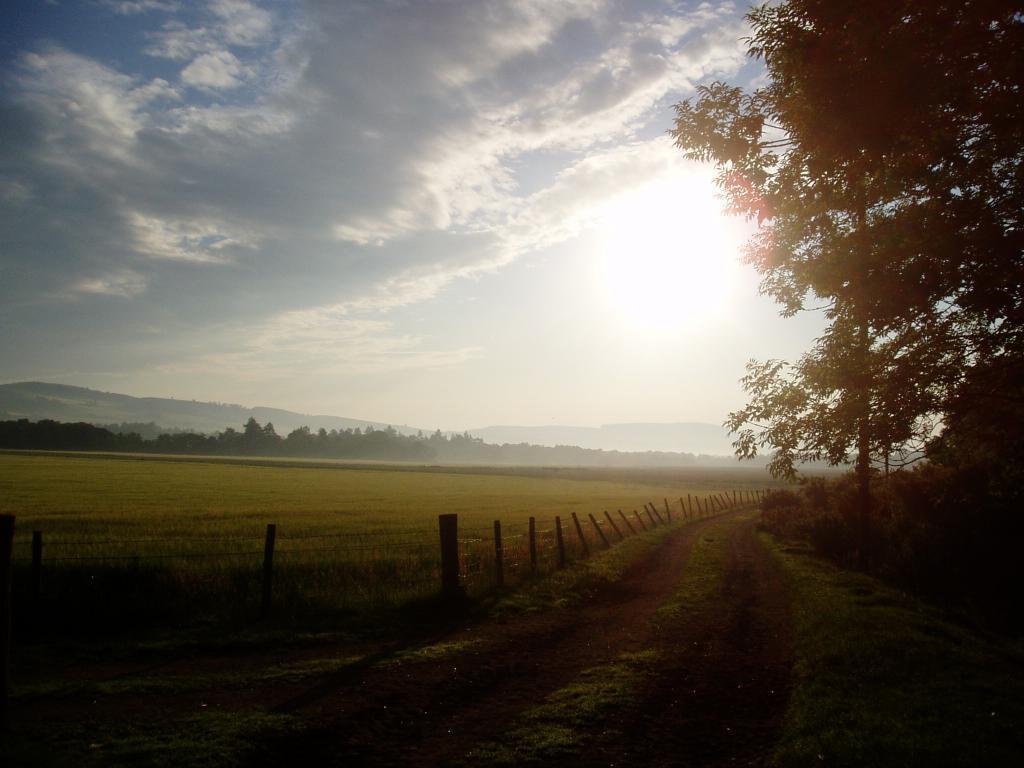How would you summarize this image in a sentence or two? In this image we can see some trees, grass and the pathway. On the left side we can see some poles, plants, a group of trees and the sky which looks cloudy. 